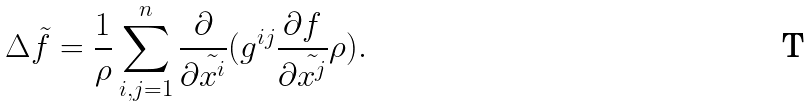Convert formula to latex. <formula><loc_0><loc_0><loc_500><loc_500>\Delta \tilde { f } = \frac { 1 } { \rho } \sum _ { i , j = 1 } ^ { n } \frac { \partial } { \partial \tilde { x ^ { i } } } ( g ^ { i j } \frac { \partial f } { \partial \tilde { x ^ { j } } } \rho ) .</formula> 